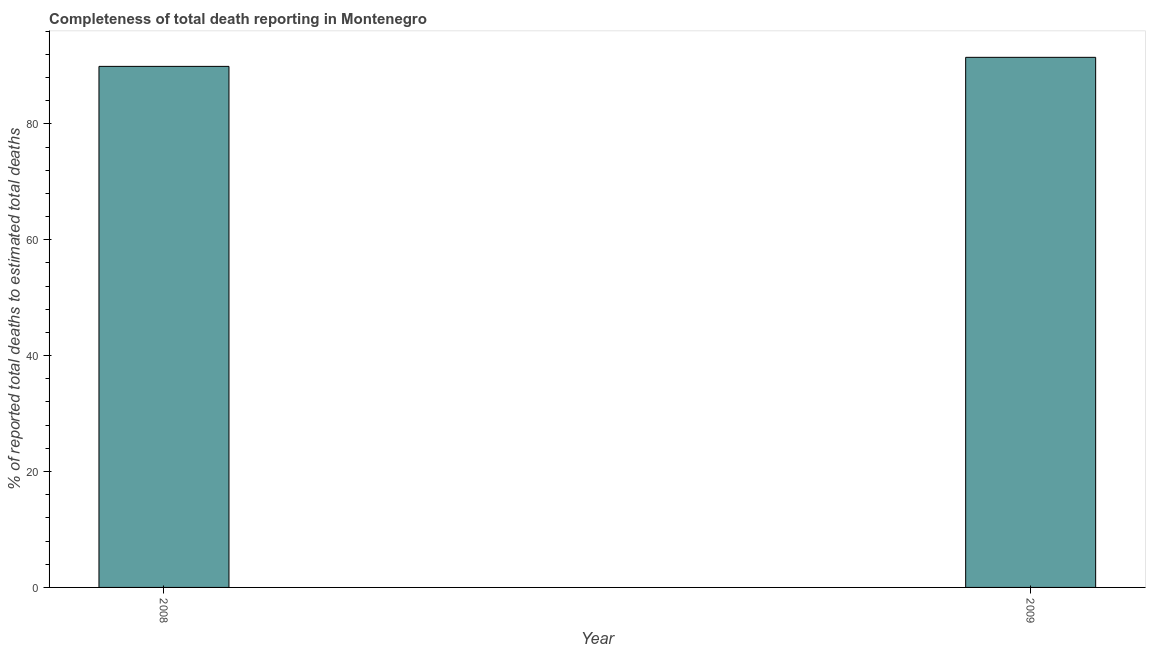Does the graph contain any zero values?
Offer a very short reply. No. What is the title of the graph?
Keep it short and to the point. Completeness of total death reporting in Montenegro. What is the label or title of the X-axis?
Your response must be concise. Year. What is the label or title of the Y-axis?
Give a very brief answer. % of reported total deaths to estimated total deaths. What is the completeness of total death reports in 2009?
Provide a succinct answer. 91.48. Across all years, what is the maximum completeness of total death reports?
Give a very brief answer. 91.48. Across all years, what is the minimum completeness of total death reports?
Offer a very short reply. 89.92. In which year was the completeness of total death reports maximum?
Provide a short and direct response. 2009. What is the sum of the completeness of total death reports?
Your answer should be compact. 181.4. What is the difference between the completeness of total death reports in 2008 and 2009?
Your answer should be very brief. -1.56. What is the average completeness of total death reports per year?
Keep it short and to the point. 90.7. What is the median completeness of total death reports?
Offer a terse response. 90.7. Do a majority of the years between 2008 and 2009 (inclusive) have completeness of total death reports greater than 88 %?
Keep it short and to the point. Yes. What is the ratio of the completeness of total death reports in 2008 to that in 2009?
Give a very brief answer. 0.98. Is the completeness of total death reports in 2008 less than that in 2009?
Provide a short and direct response. Yes. In how many years, is the completeness of total death reports greater than the average completeness of total death reports taken over all years?
Your response must be concise. 1. How many years are there in the graph?
Ensure brevity in your answer.  2. Are the values on the major ticks of Y-axis written in scientific E-notation?
Provide a succinct answer. No. What is the % of reported total deaths to estimated total deaths in 2008?
Keep it short and to the point. 89.92. What is the % of reported total deaths to estimated total deaths of 2009?
Keep it short and to the point. 91.48. What is the difference between the % of reported total deaths to estimated total deaths in 2008 and 2009?
Offer a very short reply. -1.56. 